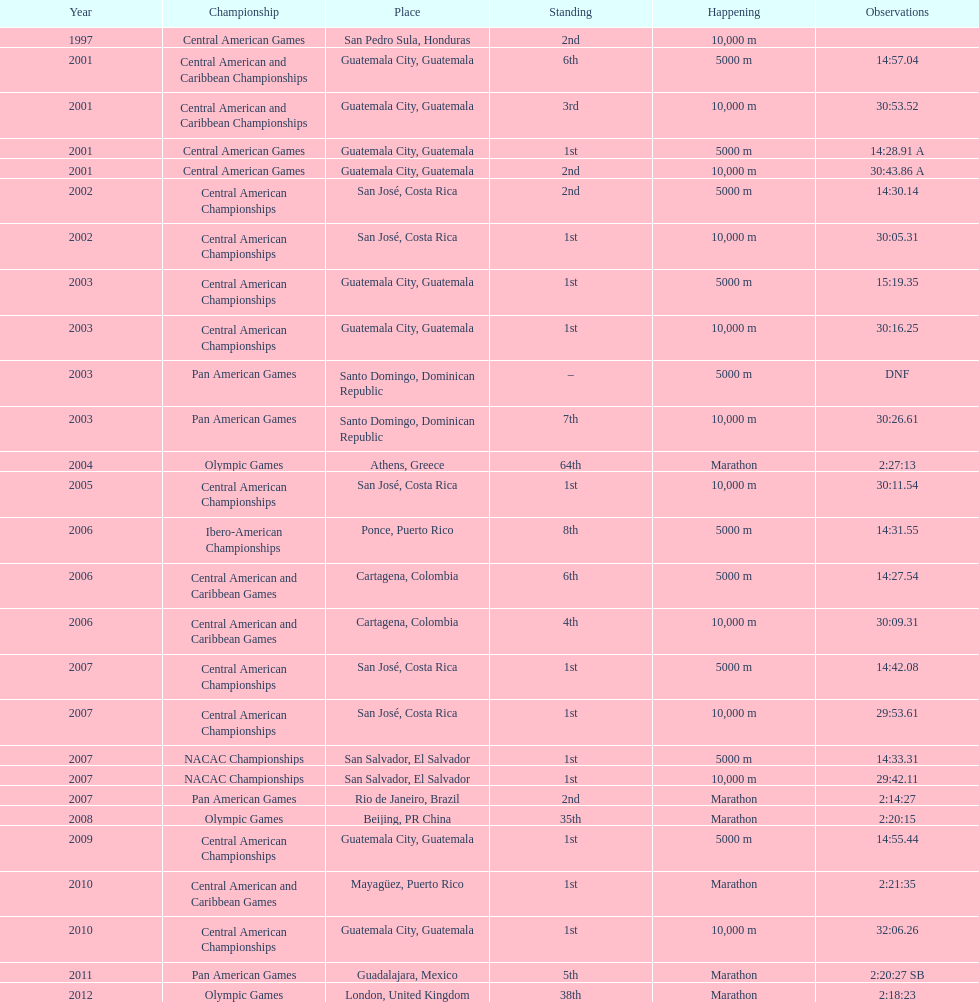How many times has this athlete not finished in a competition? 1. 